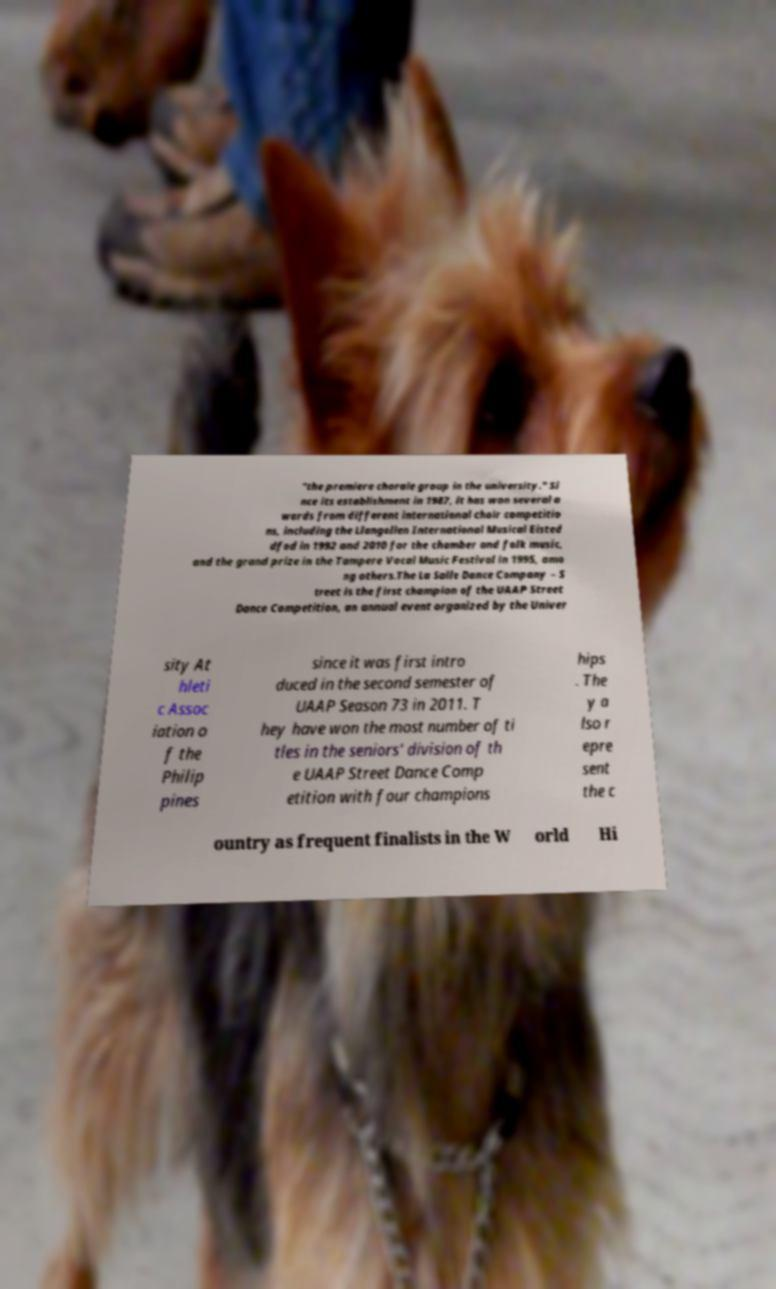Can you accurately transcribe the text from the provided image for me? "the premiere chorale group in the university." Si nce its establishment in 1987, it has won several a wards from different international choir competitio ns, including the Llangollen International Musical Eisted dfod in 1992 and 2010 for the chamber and folk music, and the grand prize in the Tampere Vocal Music Festival in 1995, amo ng others.The La Salle Dance Company – S treet is the first champion of the UAAP Street Dance Competition, an annual event organized by the Univer sity At hleti c Assoc iation o f the Philip pines since it was first intro duced in the second semester of UAAP Season 73 in 2011. T hey have won the most number of ti tles in the seniors' division of th e UAAP Street Dance Comp etition with four champions hips . The y a lso r epre sent the c ountry as frequent finalists in the W orld Hi 